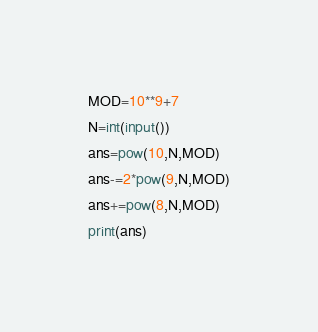Convert code to text. <code><loc_0><loc_0><loc_500><loc_500><_Python_>MOD=10**9+7
N=int(input())
ans=pow(10,N,MOD)
ans-=2*pow(9,N,MOD)
ans+=pow(8,N,MOD)
print(ans)</code> 